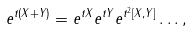<formula> <loc_0><loc_0><loc_500><loc_500>e ^ { t ( X + Y ) } = e ^ { t X } e ^ { t Y } e ^ { t ^ { 2 } [ X , Y ] } \dots ,</formula> 